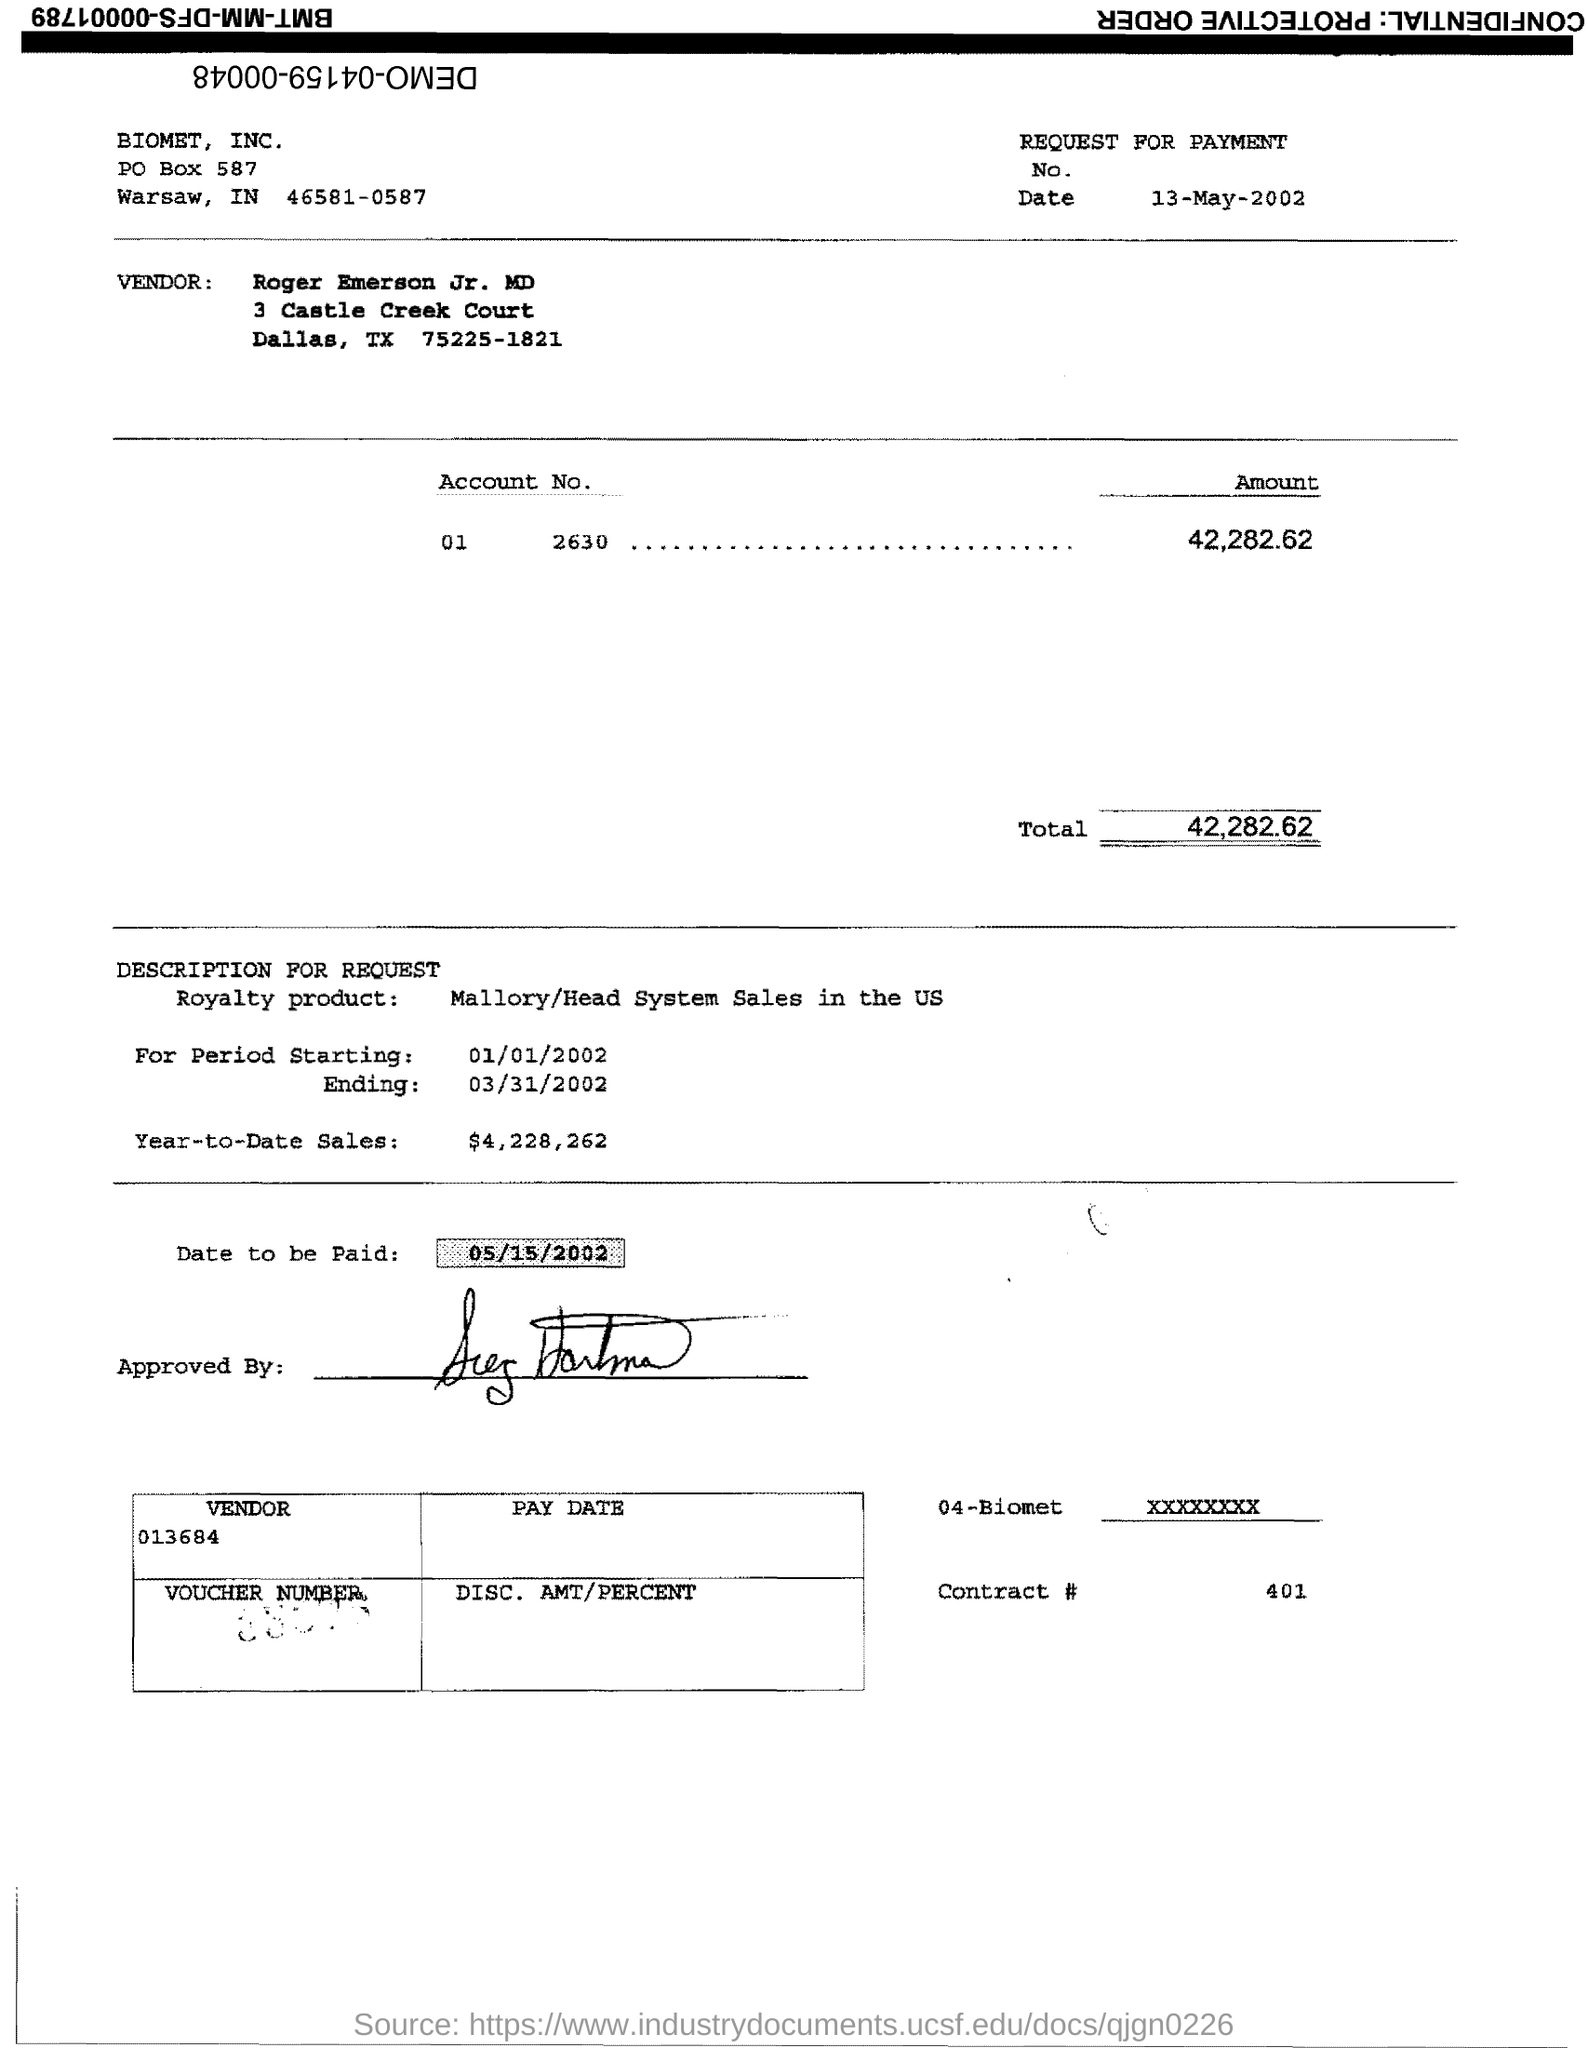Point out several critical features in this image. The PO Box number mentioned in the document is 587. The total is 42,282.62 dollars. I hereby declare that the contract number is 401... 